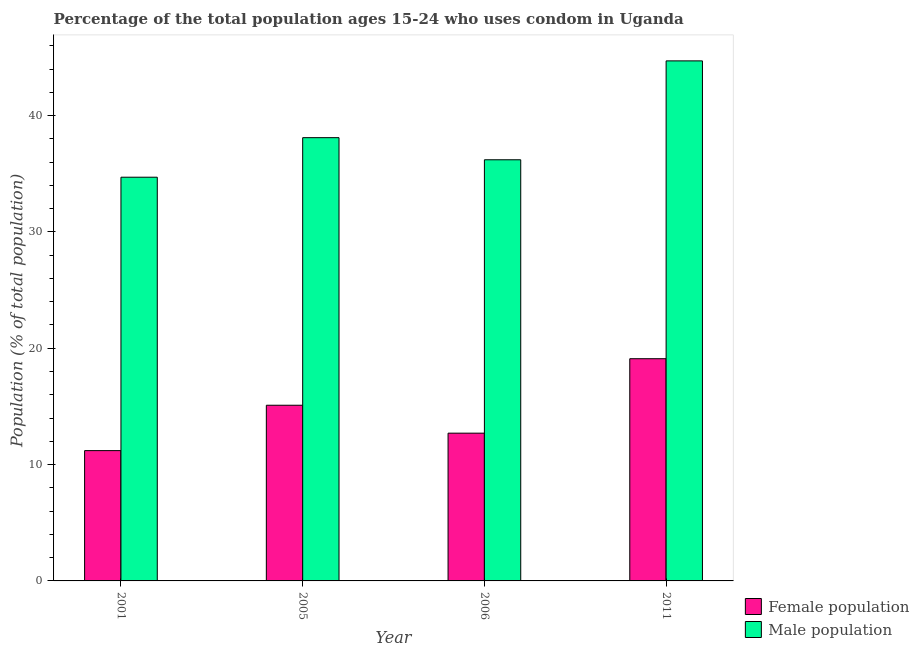How many different coloured bars are there?
Provide a short and direct response. 2. How many groups of bars are there?
Make the answer very short. 4. How many bars are there on the 3rd tick from the right?
Your answer should be very brief. 2. In how many cases, is the number of bars for a given year not equal to the number of legend labels?
Keep it short and to the point. 0. What is the female population in 2006?
Provide a short and direct response. 12.7. Across all years, what is the maximum male population?
Your answer should be compact. 44.7. Across all years, what is the minimum female population?
Provide a short and direct response. 11.2. What is the total male population in the graph?
Your answer should be compact. 153.7. What is the difference between the male population in 2001 and that in 2005?
Your response must be concise. -3.4. What is the difference between the female population in 2011 and the male population in 2005?
Your response must be concise. 4. What is the average female population per year?
Provide a short and direct response. 14.53. In the year 2001, what is the difference between the female population and male population?
Provide a short and direct response. 0. What is the ratio of the male population in 2006 to that in 2011?
Give a very brief answer. 0.81. Is the difference between the female population in 2005 and 2011 greater than the difference between the male population in 2005 and 2011?
Your answer should be compact. No. What is the difference between the highest and the second highest male population?
Ensure brevity in your answer.  6.6. What is the difference between the highest and the lowest female population?
Your answer should be compact. 7.9. In how many years, is the female population greater than the average female population taken over all years?
Keep it short and to the point. 2. What does the 1st bar from the left in 2006 represents?
Provide a short and direct response. Female population. What does the 1st bar from the right in 2005 represents?
Provide a short and direct response. Male population. How many bars are there?
Provide a succinct answer. 8. How many years are there in the graph?
Give a very brief answer. 4. Does the graph contain grids?
Ensure brevity in your answer.  No. How many legend labels are there?
Provide a short and direct response. 2. How are the legend labels stacked?
Your answer should be compact. Vertical. What is the title of the graph?
Your answer should be compact. Percentage of the total population ages 15-24 who uses condom in Uganda. Does "Overweight" appear as one of the legend labels in the graph?
Keep it short and to the point. No. What is the label or title of the Y-axis?
Make the answer very short. Population (% of total population) . What is the Population (% of total population)  of Female population in 2001?
Your answer should be very brief. 11.2. What is the Population (% of total population)  of Male population in 2001?
Provide a short and direct response. 34.7. What is the Population (% of total population)  in Male population in 2005?
Give a very brief answer. 38.1. What is the Population (% of total population)  in Male population in 2006?
Offer a very short reply. 36.2. What is the Population (% of total population)  of Male population in 2011?
Give a very brief answer. 44.7. Across all years, what is the maximum Population (% of total population)  of Male population?
Your answer should be compact. 44.7. Across all years, what is the minimum Population (% of total population)  of Male population?
Offer a terse response. 34.7. What is the total Population (% of total population)  of Female population in the graph?
Offer a terse response. 58.1. What is the total Population (% of total population)  of Male population in the graph?
Ensure brevity in your answer.  153.7. What is the difference between the Population (% of total population)  of Male population in 2001 and that in 2005?
Provide a short and direct response. -3.4. What is the difference between the Population (% of total population)  of Female population in 2001 and that in 2006?
Keep it short and to the point. -1.5. What is the difference between the Population (% of total population)  in Female population in 2005 and that in 2011?
Your answer should be very brief. -4. What is the difference between the Population (% of total population)  in Male population in 2006 and that in 2011?
Give a very brief answer. -8.5. What is the difference between the Population (% of total population)  of Female population in 2001 and the Population (% of total population)  of Male population in 2005?
Your answer should be very brief. -26.9. What is the difference between the Population (% of total population)  of Female population in 2001 and the Population (% of total population)  of Male population in 2006?
Your answer should be very brief. -25. What is the difference between the Population (% of total population)  in Female population in 2001 and the Population (% of total population)  in Male population in 2011?
Ensure brevity in your answer.  -33.5. What is the difference between the Population (% of total population)  of Female population in 2005 and the Population (% of total population)  of Male population in 2006?
Give a very brief answer. -21.1. What is the difference between the Population (% of total population)  of Female population in 2005 and the Population (% of total population)  of Male population in 2011?
Give a very brief answer. -29.6. What is the difference between the Population (% of total population)  of Female population in 2006 and the Population (% of total population)  of Male population in 2011?
Give a very brief answer. -32. What is the average Population (% of total population)  in Female population per year?
Your answer should be very brief. 14.53. What is the average Population (% of total population)  of Male population per year?
Ensure brevity in your answer.  38.42. In the year 2001, what is the difference between the Population (% of total population)  of Female population and Population (% of total population)  of Male population?
Provide a succinct answer. -23.5. In the year 2006, what is the difference between the Population (% of total population)  in Female population and Population (% of total population)  in Male population?
Provide a short and direct response. -23.5. In the year 2011, what is the difference between the Population (% of total population)  in Female population and Population (% of total population)  in Male population?
Offer a very short reply. -25.6. What is the ratio of the Population (% of total population)  of Female population in 2001 to that in 2005?
Provide a short and direct response. 0.74. What is the ratio of the Population (% of total population)  in Male population in 2001 to that in 2005?
Keep it short and to the point. 0.91. What is the ratio of the Population (% of total population)  of Female population in 2001 to that in 2006?
Offer a very short reply. 0.88. What is the ratio of the Population (% of total population)  of Male population in 2001 to that in 2006?
Provide a succinct answer. 0.96. What is the ratio of the Population (% of total population)  in Female population in 2001 to that in 2011?
Keep it short and to the point. 0.59. What is the ratio of the Population (% of total population)  of Male population in 2001 to that in 2011?
Your answer should be very brief. 0.78. What is the ratio of the Population (% of total population)  of Female population in 2005 to that in 2006?
Your answer should be very brief. 1.19. What is the ratio of the Population (% of total population)  of Male population in 2005 to that in 2006?
Your response must be concise. 1.05. What is the ratio of the Population (% of total population)  in Female population in 2005 to that in 2011?
Ensure brevity in your answer.  0.79. What is the ratio of the Population (% of total population)  in Male population in 2005 to that in 2011?
Make the answer very short. 0.85. What is the ratio of the Population (% of total population)  in Female population in 2006 to that in 2011?
Your answer should be very brief. 0.66. What is the ratio of the Population (% of total population)  in Male population in 2006 to that in 2011?
Offer a terse response. 0.81. What is the difference between the highest and the second highest Population (% of total population)  in Male population?
Offer a very short reply. 6.6. What is the difference between the highest and the lowest Population (% of total population)  of Male population?
Provide a short and direct response. 10. 